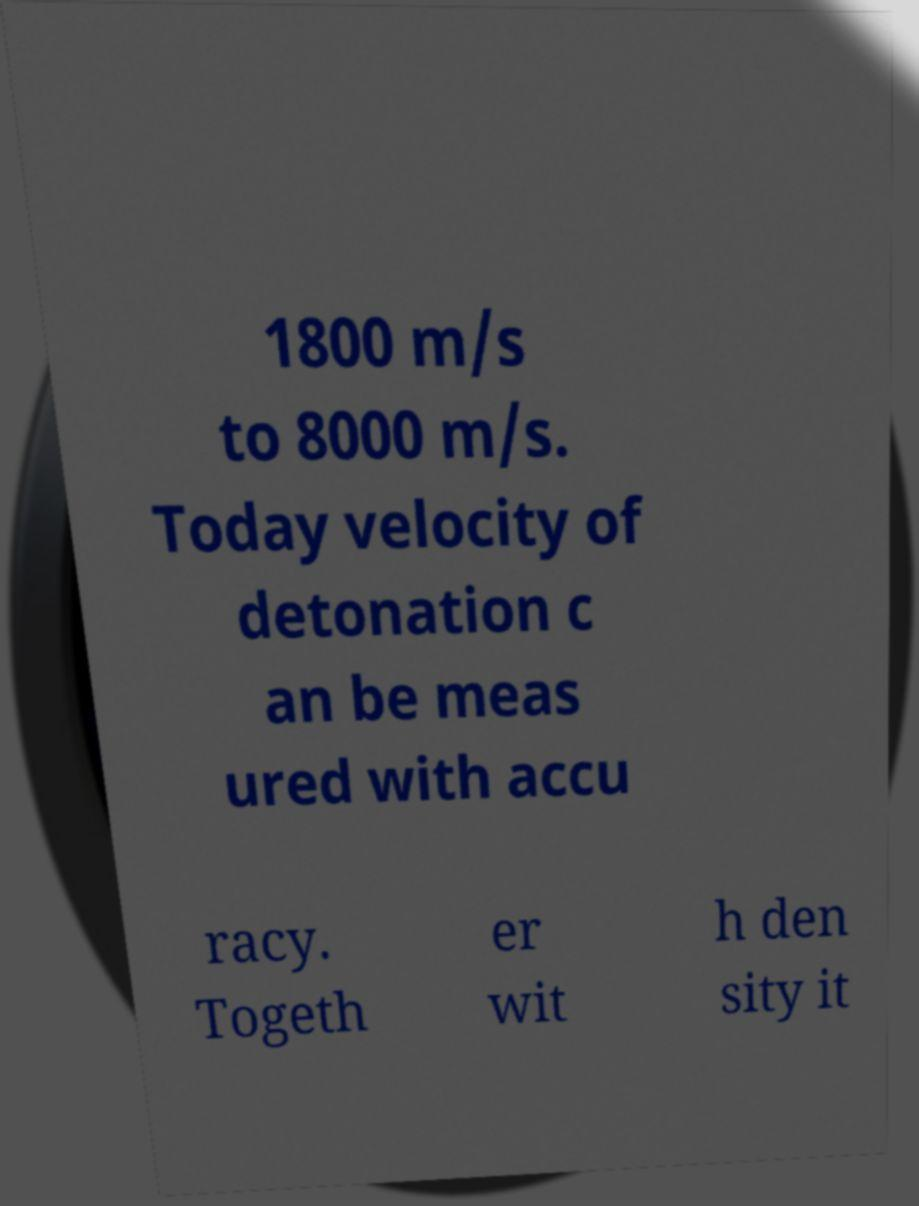Can you accurately transcribe the text from the provided image for me? 1800 m/s to 8000 m/s. Today velocity of detonation c an be meas ured with accu racy. Togeth er wit h den sity it 